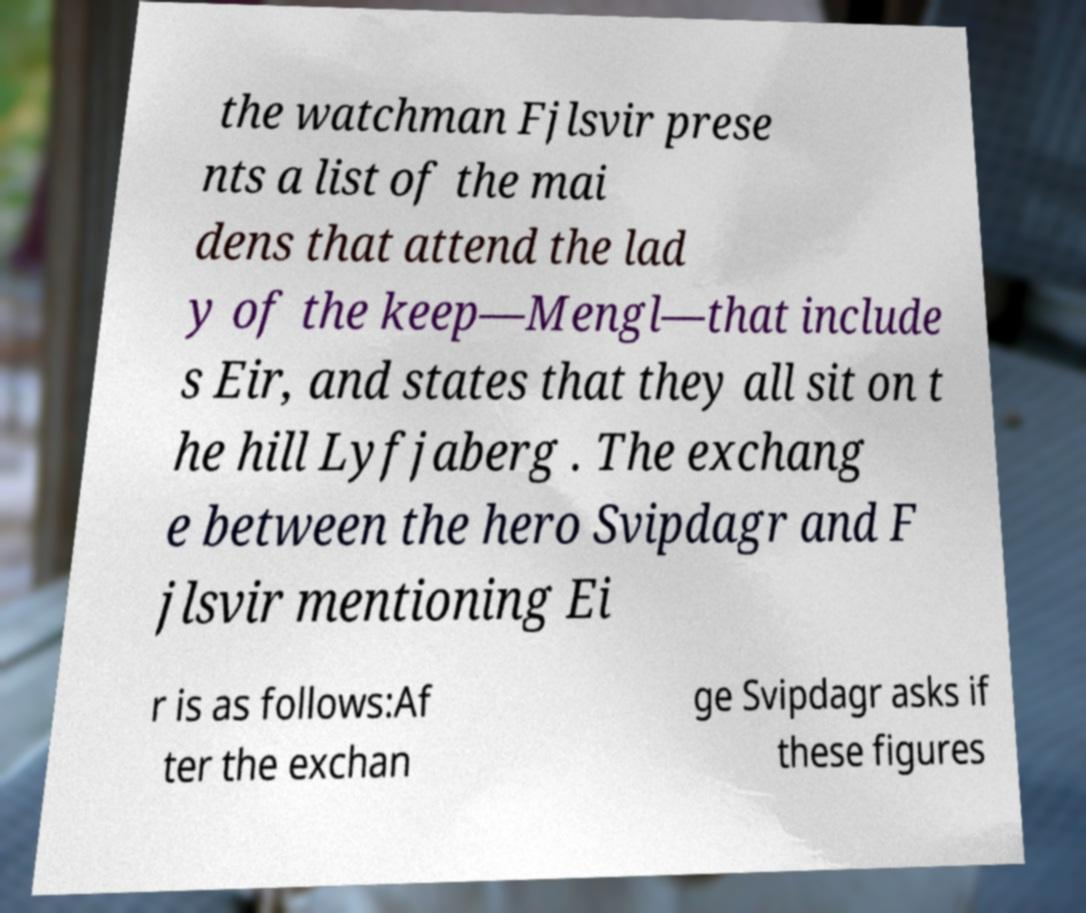Can you read and provide the text displayed in the image?This photo seems to have some interesting text. Can you extract and type it out for me? the watchman Fjlsvir prese nts a list of the mai dens that attend the lad y of the keep—Mengl—that include s Eir, and states that they all sit on t he hill Lyfjaberg . The exchang e between the hero Svipdagr and F jlsvir mentioning Ei r is as follows:Af ter the exchan ge Svipdagr asks if these figures 